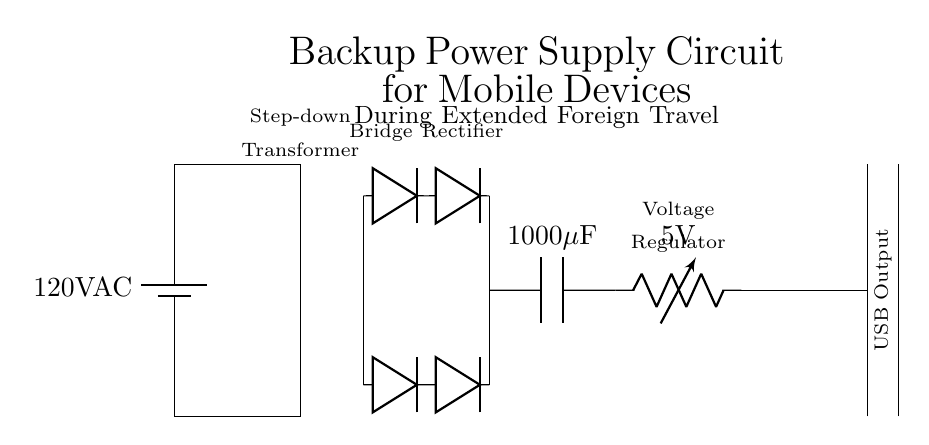What is the input voltage of the circuit? The input voltage is noted as 120V AC, which is listed alongside the battery symbol in the circuit diagram.
Answer: 120V AC What is the role of the transformer in this circuit? The transformer is used to step down the voltage from 120V AC to a lower level suitable for charging mobile devices, indicated by its placement after the input source.
Answer: Step-down What is the capacity of the capacitor used in this circuit? The circuit diagram specifies a capacitor with a capacity of 1000 microfarads, which is directly labeled next to the capacitor symbol.
Answer: 1000 microfarads What is the output voltage of the voltage regulator? The voltage regulator is labeled with an output voltage of 5V, which indicates the regulated voltage output provided for USB devices.
Answer: 5V How many diodes are present in the bridge rectifier? The bridge rectifier in the circuit consists of four diodes, two pointed upwards and two downwards, forming a bridge configuration.
Answer: Four Why is this circuit important for extended foreign travel? This circuit provides a reliable backup power supply for mobile devices, ensuring that travelers can charge their devices when access to conventional power sources may be limited.
Answer: Reliable charging What type of output interface does the circuit provide? The circuit diagram indicates a USB output interface, which is a standard connection for charging many mobile devices, denoted with a label beside the output connection.
Answer: USB output 